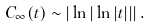<formula> <loc_0><loc_0><loc_500><loc_500>C _ { \infty } ( t ) \sim | \ln { | \ln { | t | } | } | \, .</formula> 